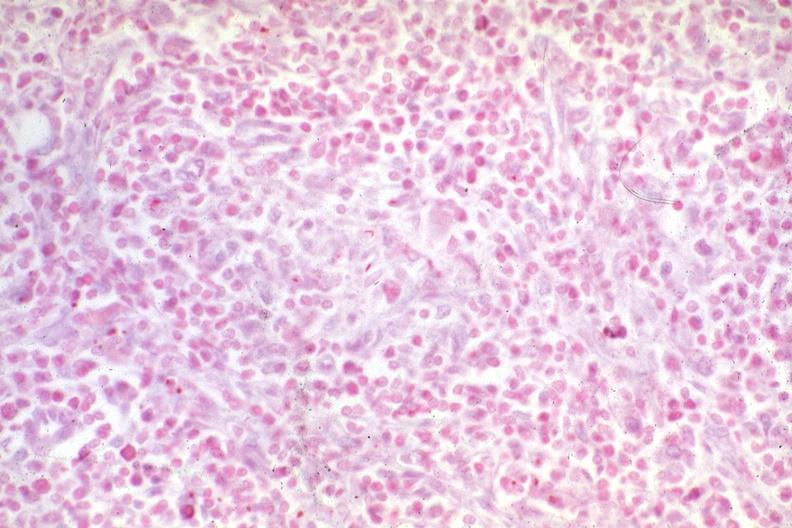what is present?
Answer the question using a single word or phrase. Mycobacterium avium intracellulare 